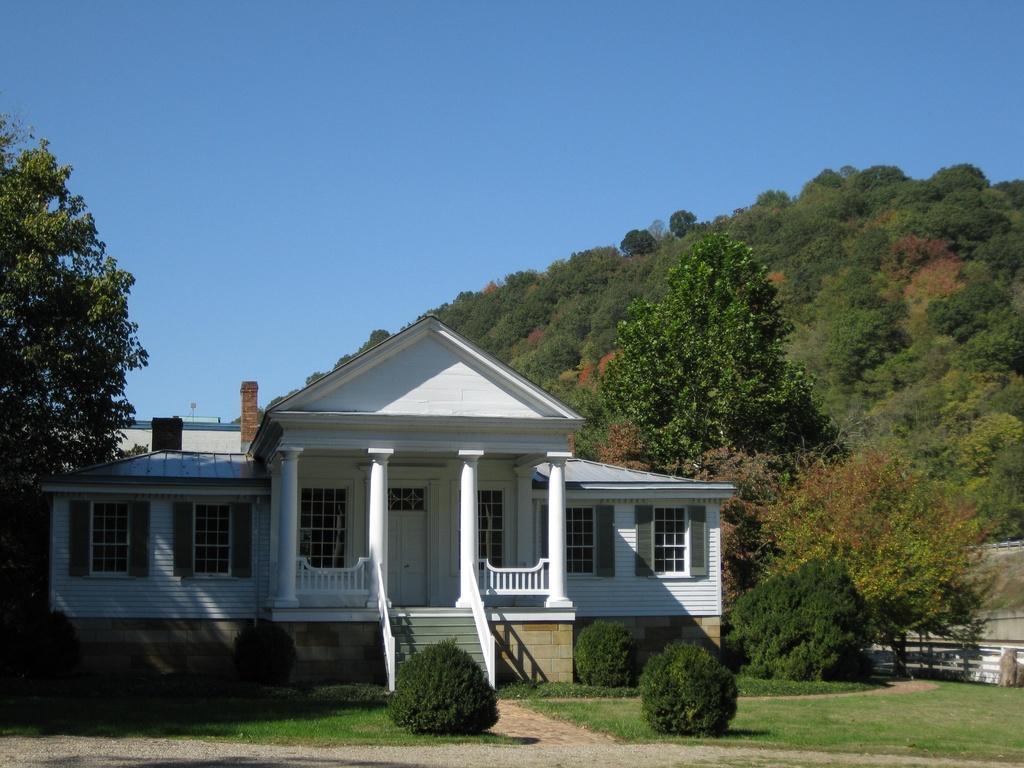In one or two sentences, can you explain what this image depicts? In this image, we can see trees, houses, plants and there are hills. At the top, there is sky and at the bottom, there is ground. 